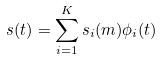Convert formula to latex. <formula><loc_0><loc_0><loc_500><loc_500>s ( t ) = \sum _ { i = 1 } ^ { K } s _ { i } ( m ) \phi _ { i } ( t )</formula> 